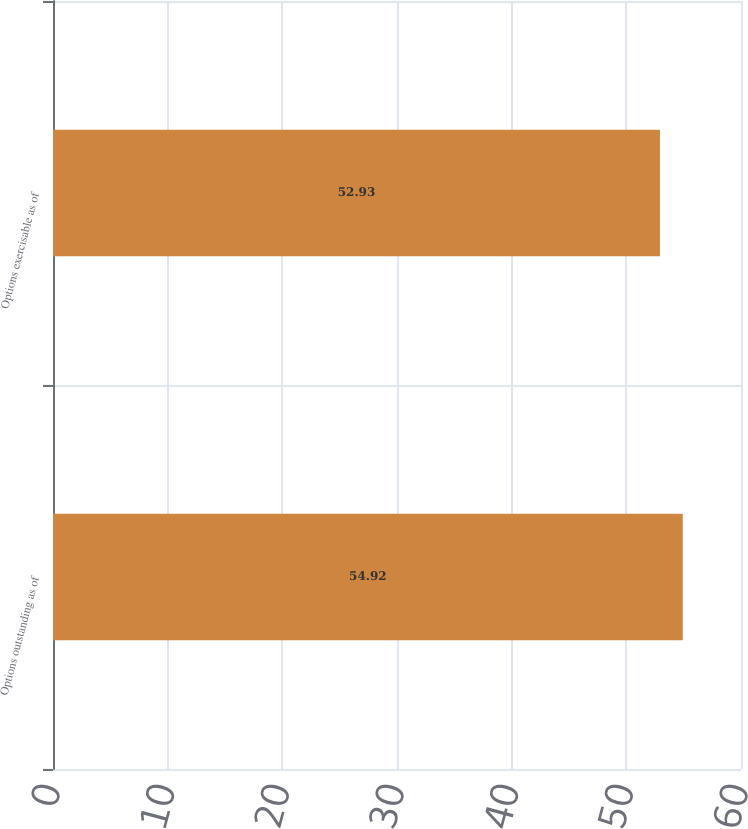<chart> <loc_0><loc_0><loc_500><loc_500><bar_chart><fcel>Options outstanding as of<fcel>Options exercisable as of<nl><fcel>54.92<fcel>52.93<nl></chart> 